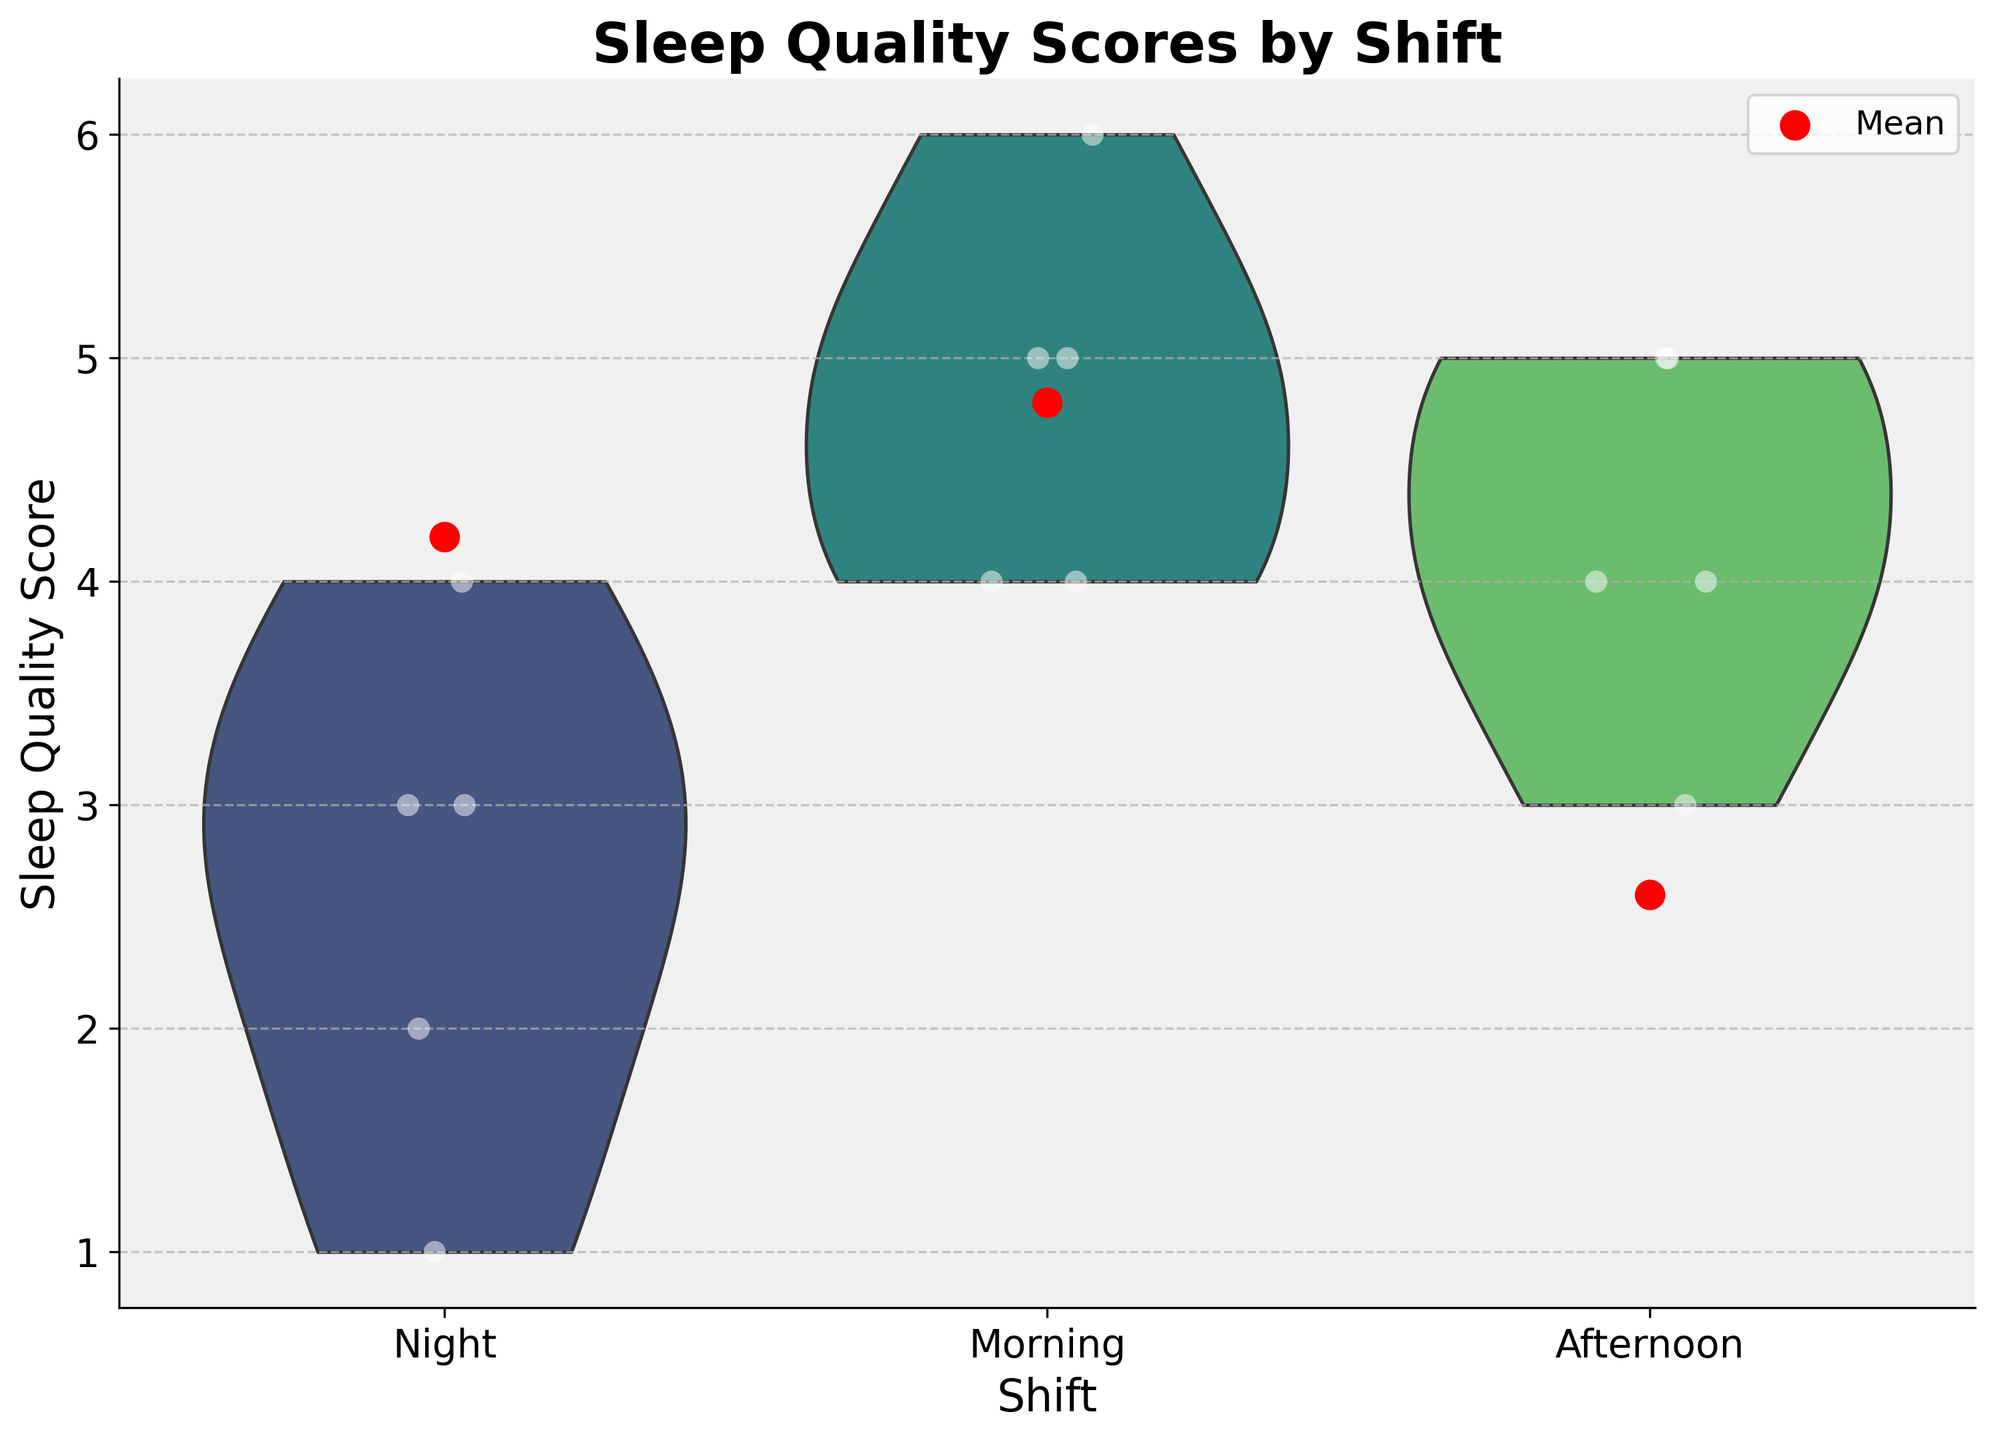What do the colors represent? The colors represent different shifts: the palette 'viridis' is used to color the violin plots differently.
Answer: Shifts What does the red dot on the chart indicate? The red dots represent the mean sleep quality scores for each shift.
Answer: Mean sleep quality scores Which shift has the highest mean sleep quality score? By looking at the red dots on the chart, the Morning shift has the highest mean score.
Answer: Morning How many points are plotted for the Night shift? There are 5 white jittered points plotted for the Night shift.
Answer: 5 What is the range of sleep quality scores for the Afternoon shift? The sleep quality scores for the Afternoon shift range from 3 to 5.
Answer: 3 to 5 Which shift shows the most variation in sleep quality scores? By analyzing the width of the violin plots, the Night shift shows the most variation.
Answer: Night Are there any outliers in the sleep quality scores for any shift? There do not appear to be any outliers in the sleep quality scores, as there are no points significantly away from the violin plots.
Answer: No Which shift has the most compact distribution of sleep quality scores? The Morning shift has the most compact distribution indicated by the relatively narrow violin plot and concentrated jittered points.
Answer: Morning How does the average sleep quality score for the Night shift compare to the Afternoon shift? The average sleep quality score for the Night shift is lower than that for the Afternoon shift, as seen from the lower position of the red dot for Night.
Answer: Lower What is the title of the chart? The title of the chart is "Sleep Quality Scores by Shift".
Answer: Sleep Quality Scores by Shift 